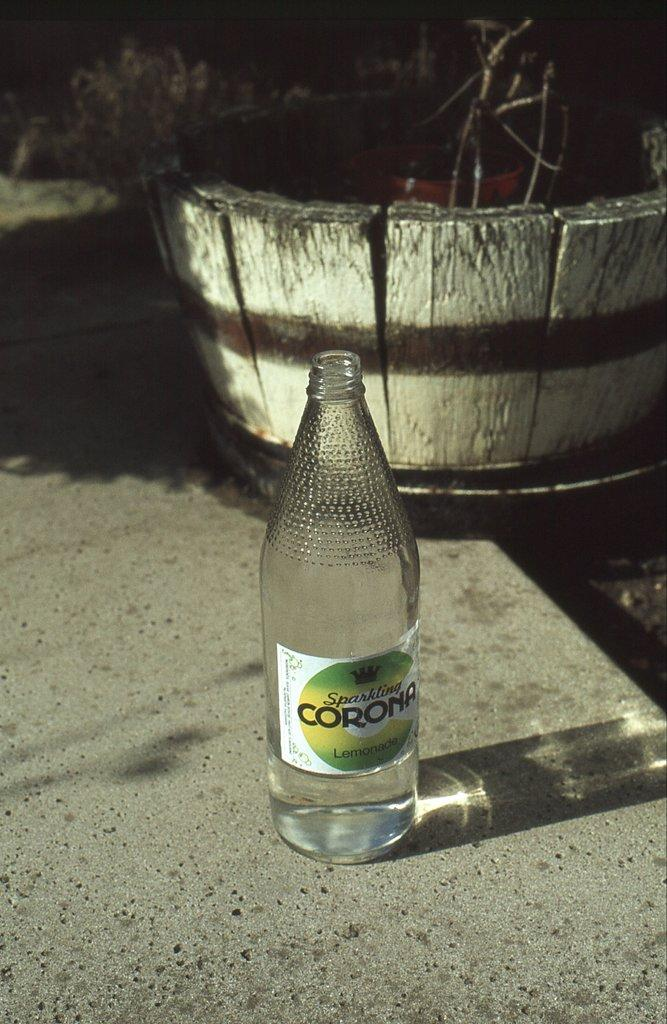Provide a one-sentence caption for the provided image. A bottle of Corona sits on the pavement empty. 